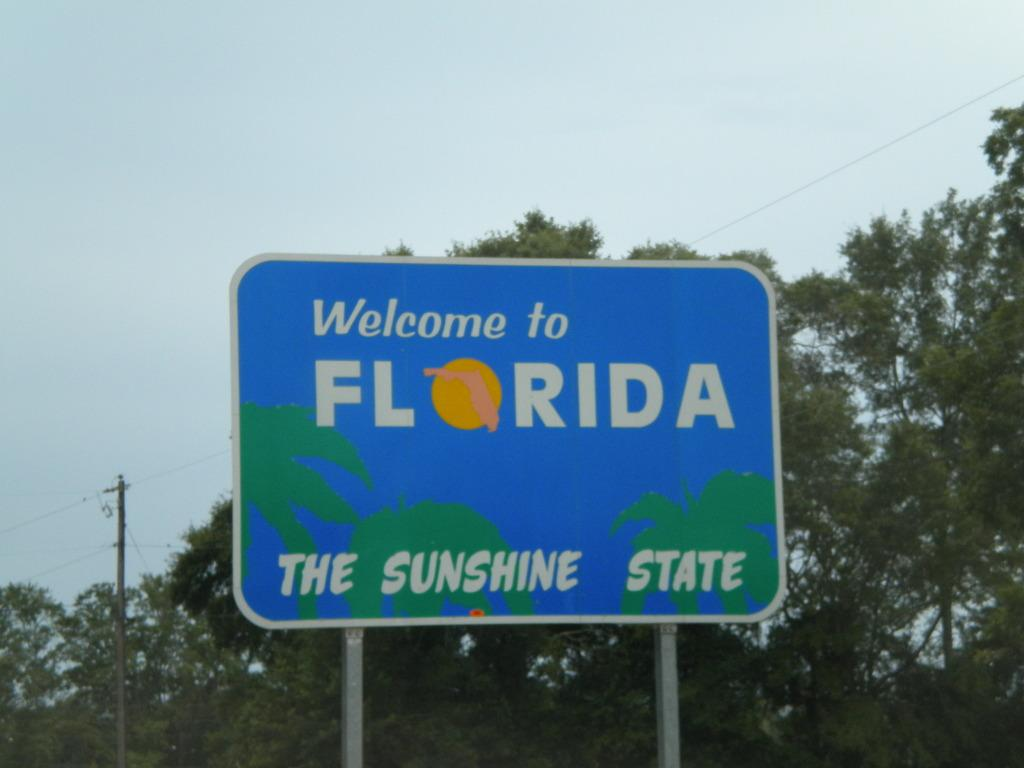<image>
Offer a succinct explanation of the picture presented. A blue sign welcomes people to Florida, the Sunshine State. 